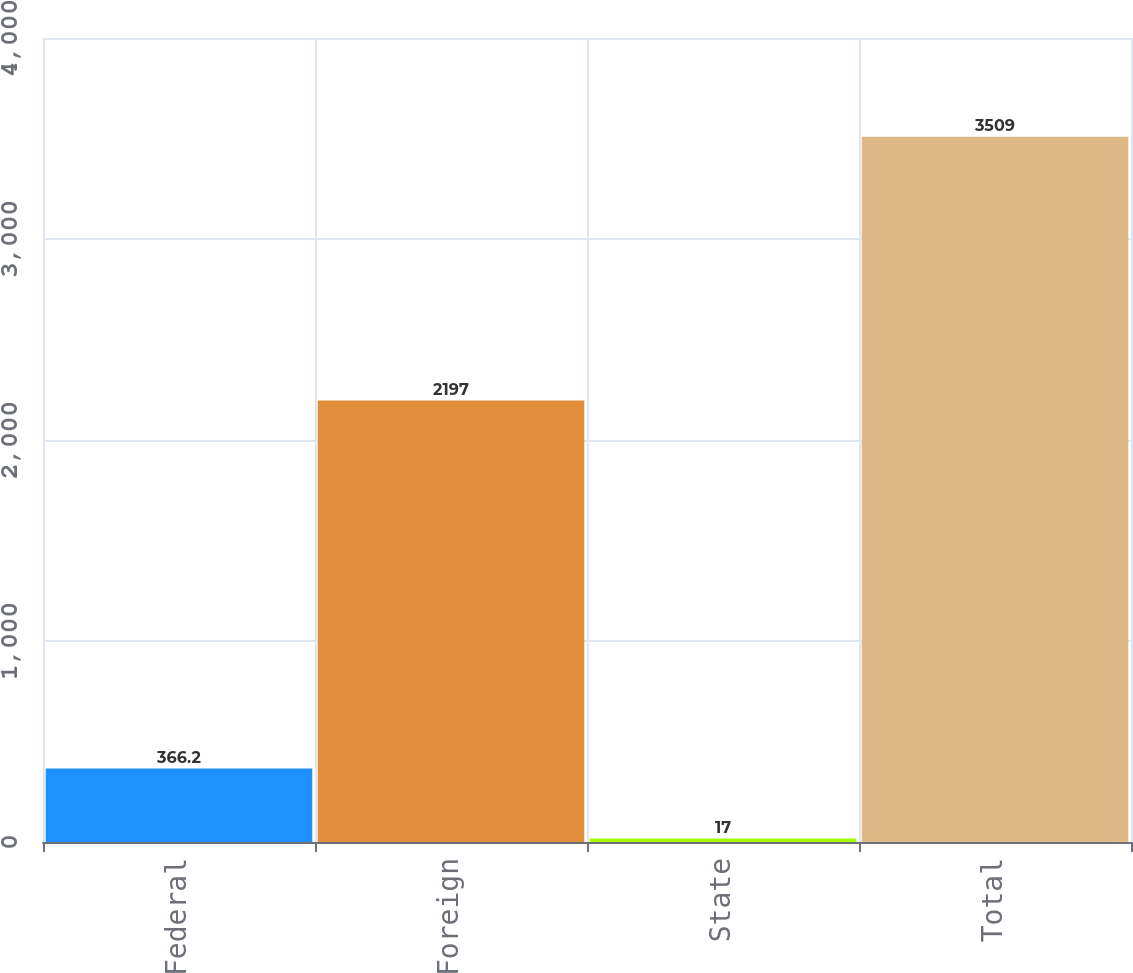Convert chart to OTSL. <chart><loc_0><loc_0><loc_500><loc_500><bar_chart><fcel>Federal<fcel>Foreign<fcel>State<fcel>Total<nl><fcel>366.2<fcel>2197<fcel>17<fcel>3509<nl></chart> 